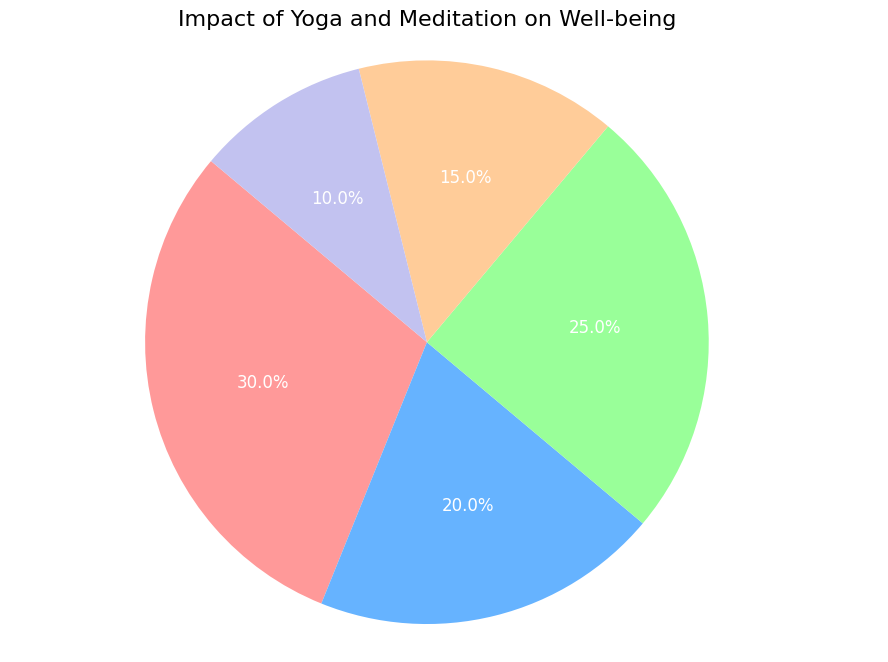What's the percentage of impact on Mental Health and Physical Health combined? Sum the percentages of Mental Health (30%) and Physical Health (20%). 30% + 20% = 50%
Answer: 50% Which category has the smallest impact on well-being? By comparing all the percentage values in the chart: Mental Health (30%), Physical Health (20%), Emotional Health (25%), Sleep Quality (15%), Overall Happiness (10%). The smallest value is 10%, which corresponds to Overall Happiness.
Answer: Overall Happiness Which category has a greater impact on well-being: Emotional Health or Sleep Quality? Compare the percentage values of Emotional Health (25%) and Sleep Quality (15%). Since 25% is greater than 15%, Emotional Health has a greater impact.
Answer: Emotional Health What's the difference in percentage impact between Emotional Health and Sleep Quality? Subtract the percentage of Sleep Quality (15%) from Emotional Health (25%). 25% - 15% = 10%
Answer: 10% Which category impacts well-being more: Physical Health or Overall Happiness? By how much? Compare the percentages of Physical Health (20%) and Overall Happiness (10%). Physical Health impacts more. Subtract the percentage of Overall Happiness from Physical Health: 20% - 10% = 10%
Answer: Physical Health by 10% How many categories have a percentage impact above 20%? Identify the categories with percentages above 20%: Mental Health (30%) and Emotional Health (25%). Count these categories: 2
Answer: 2 What is the average percentage impact of all the categories? Calculate the average by summing all percentages and dividing by the number of categories. (30% + 20% + 25% + 15% + 10%) / 5 = 100% / 5 = 20%
Answer: 20% What is the total combined impact of Physical Health, Emotional Health, and Sleep Quality? Sum the percentages: Physical Health (20%) + Emotional Health (25%) + Sleep Quality (15%). 20% + 25% + 15% = 60%
Answer: 60% If you combine Mental Health and Overall Happiness, do they together have a greater impact than Emotional Health alone? Sum the percentages of Mental Health (30%) and Overall Happiness (10%), then compare to Emotional Health (25%). 30% + 10% = 40%. Since 40% is greater than 25%, they have a greater impact together.
Answer: Yes Which categories are represented by more than one color in the pie chart? Each category in the pie chart is represented by a single distinct color. Check if any category is associated with more than one color. In this case, all categories have unique colors.
Answer: None 